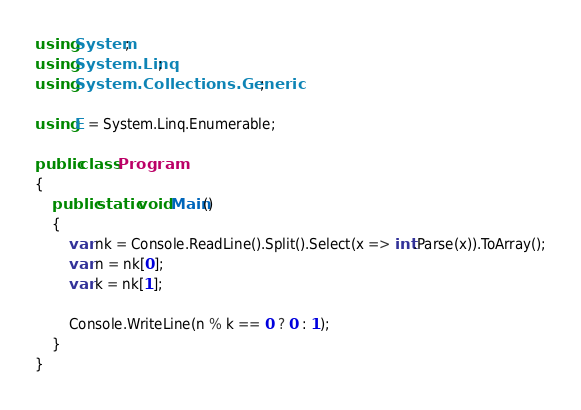<code> <loc_0><loc_0><loc_500><loc_500><_C#_>using System;
using System.Linq;
using System.Collections.Generic;

using E = System.Linq.Enumerable;

public class Program
{
    public static void Main()
    {
        var nk = Console.ReadLine().Split().Select(x => int.Parse(x)).ToArray();
        var n = nk[0];
        var k = nk[1];

        Console.WriteLine(n % k == 0 ? 0 : 1);
    }
}</code> 